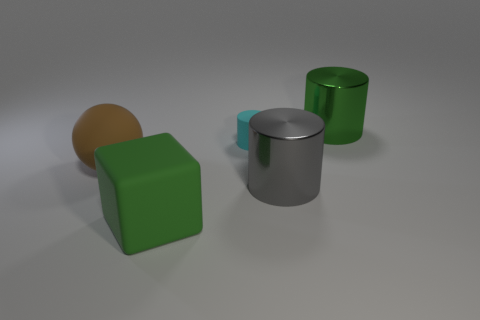Is there anything else that has the same shape as the cyan object?
Offer a terse response. Yes. The rubber sphere has what size?
Keep it short and to the point. Large. Is the number of gray metal things that are behind the cube less than the number of metallic things?
Your answer should be compact. Yes. Is the gray object the same size as the matte cylinder?
Your response must be concise. No. Are there any other things that have the same size as the cyan object?
Your response must be concise. No. There is a sphere that is made of the same material as the tiny cyan object; what is its color?
Give a very brief answer. Brown. Are there fewer gray objects that are on the right side of the large gray metal object than matte things that are behind the large rubber block?
Offer a terse response. Yes. How many cylinders have the same color as the large rubber block?
Your answer should be compact. 1. What is the material of the thing that is the same color as the large cube?
Offer a terse response. Metal. How many things are in front of the cyan object and behind the big rubber block?
Your response must be concise. 2. 